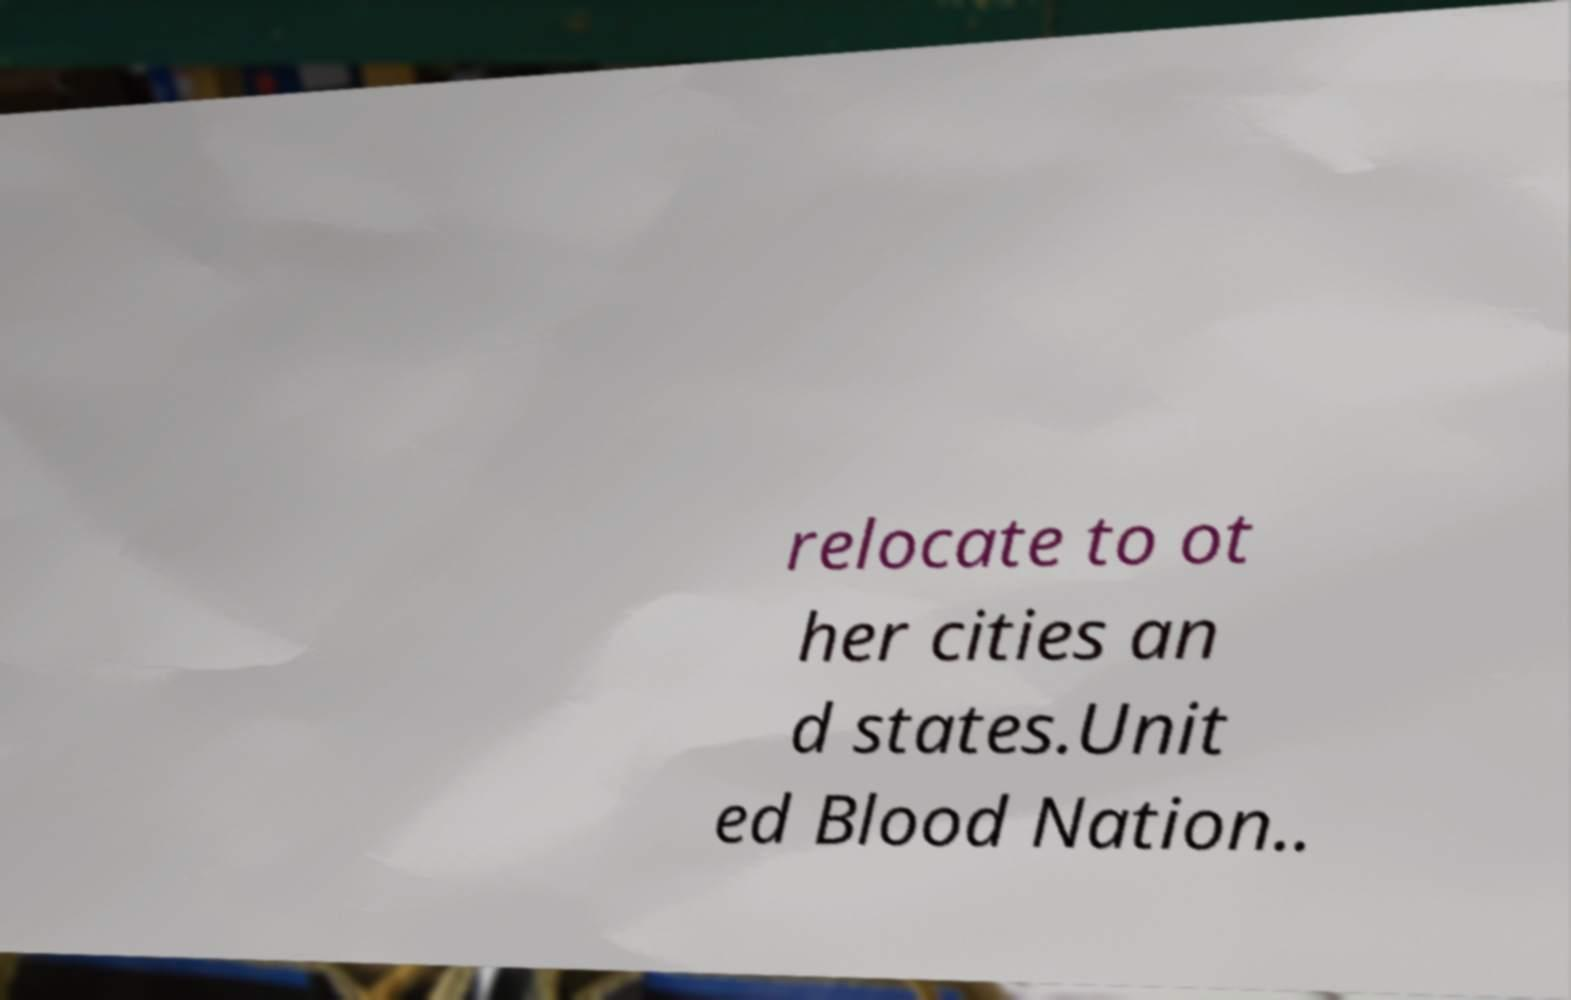Could you extract and type out the text from this image? relocate to ot her cities an d states.Unit ed Blood Nation.. 